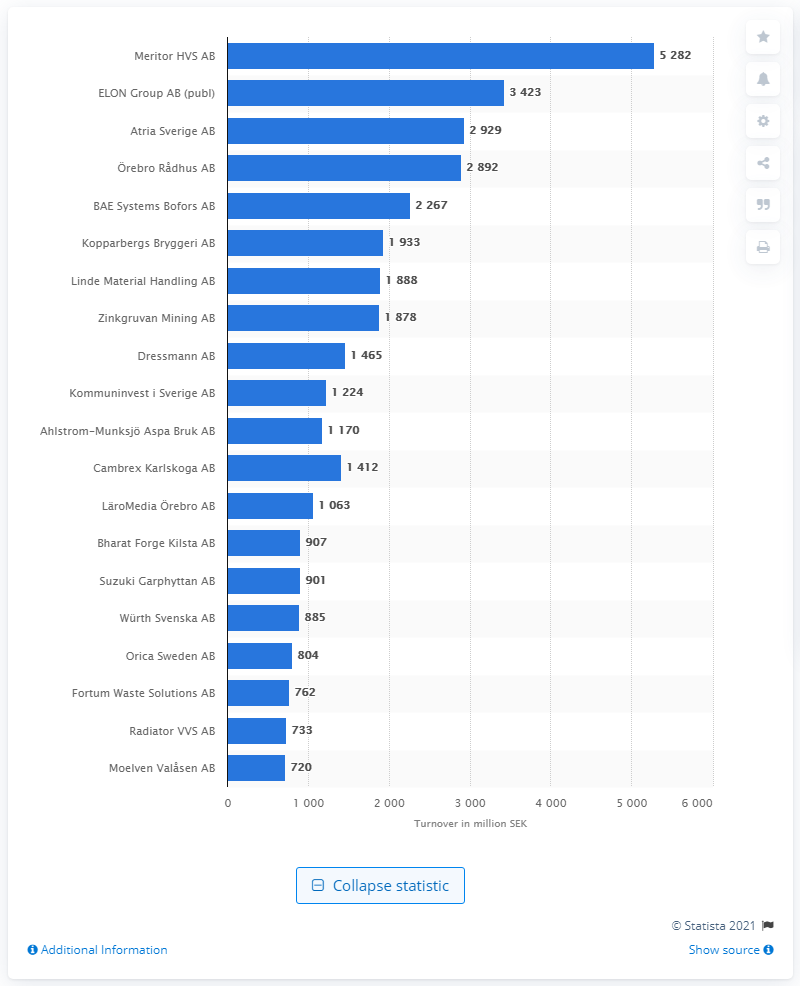Mention a couple of crucial points in this snapshot. In February 2021, Meritor HVS AB was the leading company in Västerbotten county. The turnover of ELON Group Holding AB was approximately 3423. 